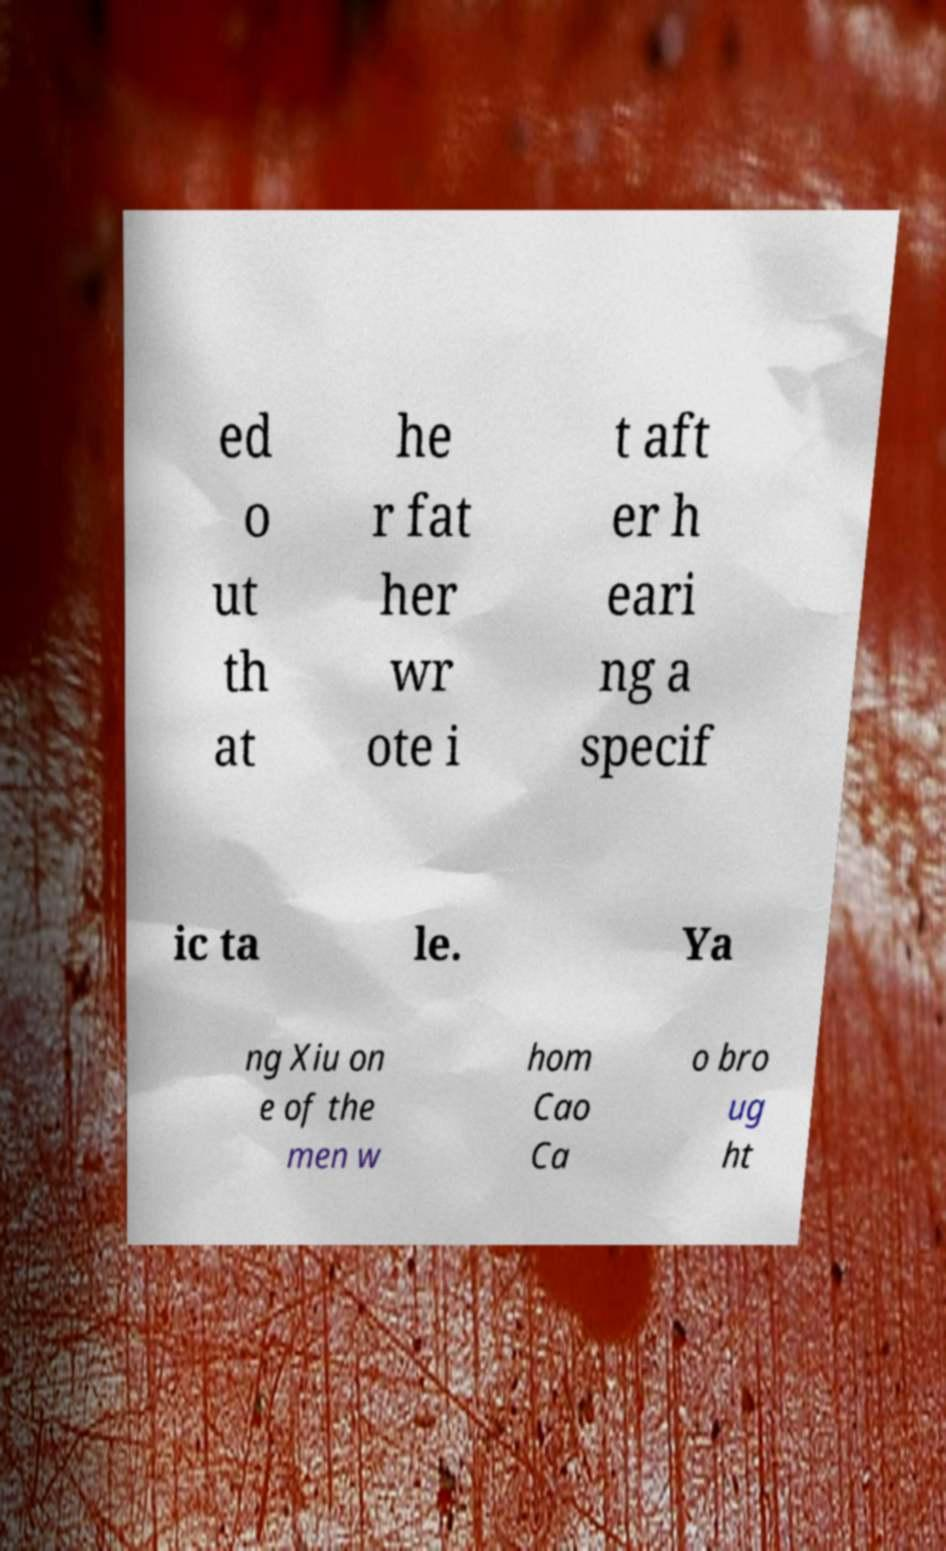Could you extract and type out the text from this image? ed o ut th at he r fat her wr ote i t aft er h eari ng a specif ic ta le. Ya ng Xiu on e of the men w hom Cao Ca o bro ug ht 